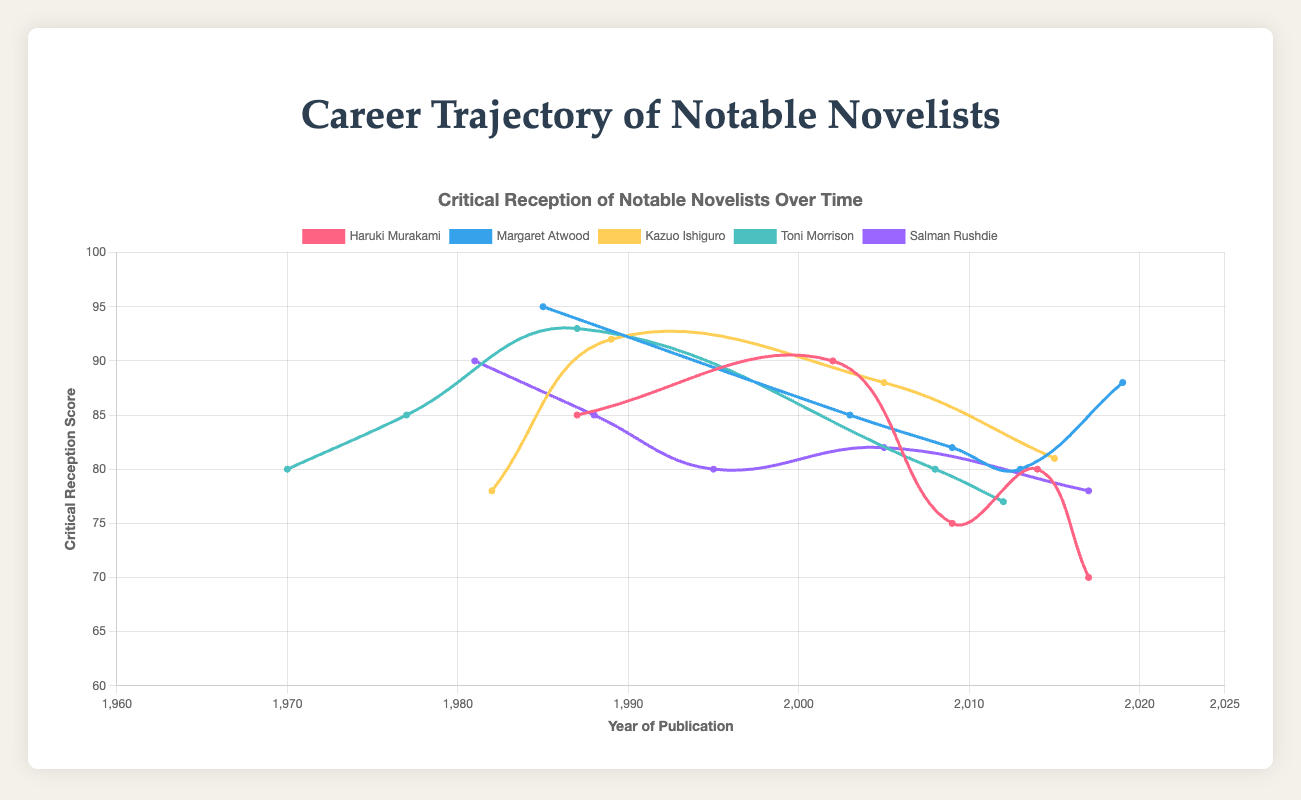Which work received the highest critical reception for Haruki Murakami? Haruki Murakami's highest critical reception score is for "Kafka on the Shore" in 2002 with a score of 90. Simply referencing the highest y-value in Murakami's line identifies this.
Answer: Kafka on the Shore How did the critical reception trend for Margaret Atwood from "The Handmaid's Tale" to "The Testaments"? The critical reception for Margaret Atwood was highest at 95 for "The Handmaid's Tale" and decreased to 80 for "MaddAddam" in 2013, then increased again to 88 for "The Testaments" in 2019. This involves checking the graph for these specific years and noting the changes.
Answer: Decrease then increase Which novelist had the most variation in critical reception over their career? By comparing the range of y-values for each novelist, Haruki Murakami shows the most variation, with scores ranging from 70 ("Killing Commendatore") to 90 ("Kafka on the Shore"), a range of 20.
Answer: Haruki Murakami What is the average critical reception score of Kazuo Ishiguro's works? Sum the critical reception scores of Kazuo Ishiguro's works (78, 92, 88, 81) and divide by the number of works: (78 + 92 + 88 + 81) / 4 = 339 / 4 = 84.75.
Answer: 84.75 Compare the critical reception of Toni Morrison's first and last listed works. Which one received higher critical reception? Toni Morrison's first work "The Bluest Eye" has a reception of 80, while her last listed work "Home" has a reception of 77. Therefore, "The Bluest Eye" received higher critical reception.
Answer: The Bluest Eye What is the difference in critical reception between Margaret Atwood's "Oryx and Crake" and "The Testaments"? "Oryx and Crake" has a critical reception of 85, and "The Testaments" has 88. The difference is 88 - 85 = 3.
Answer: 3 Which two works of Salman Rushdie have the smallest difference in critical reception? Compare reception scores of his works; “Shalimar the Clown” (82) and “The Moor's Last Sigh” (80) have the smallest difference of 2.
Answer: Shalimar the Clown and The Moor's Last Sigh What was the critical reception trend for Kazuo Ishiguro from "A Pale View of Hills" to "The Buried Giant"? For Kazuo Ishiguro, the reception score starts at 78, goes up significantly to 92 for "The Remains of the Day," slightly drops to 88 for "Never Let Me Go," and then down to 81 for "The Buried Giant," depicting an overall decreasing trend but with an initial increase.
Answer: Increase then decrease Identify the years with the highest and lowest critical reception scores for Toni Morrison. For Toni Morrison, "Beloved" in 1987 has the highest score of 93, and "Home" in 2012 has the lowest score of 77. This requires identifying the extreme y-values on her chart line.
Answer: 1987 and 2012 How many novelists have a work with a critical reception score of 85? Listing the works for each novelist, Margaret Atwood ("Oryx and Crake"), Salman Rushdie ("The Satanic Verses"), Haruki Murakami ("Norwegian Wood"), and Toni Morrison ("Song of Solomon") all have work with an 85 score. Count them up to get the total number of novelists.
Answer: 4 